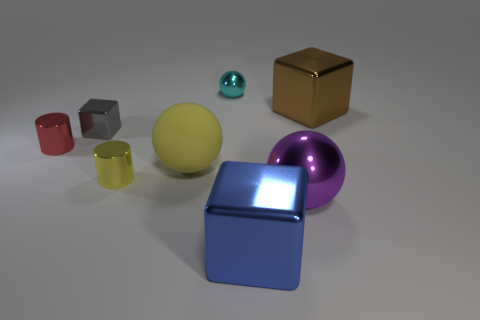Add 1 tiny yellow cylinders. How many objects exist? 9 Subtract all big purple balls. How many balls are left? 2 Subtract all yellow cylinders. How many cylinders are left? 1 Subtract all cylinders. How many objects are left? 6 Subtract 1 blocks. How many blocks are left? 2 Subtract all green cylinders. Subtract all purple cubes. How many cylinders are left? 2 Subtract all yellow cubes. How many green cylinders are left? 0 Subtract all metallic balls. Subtract all small yellow shiny objects. How many objects are left? 5 Add 1 small red metallic things. How many small red metallic things are left? 2 Add 1 tiny brown balls. How many tiny brown balls exist? 1 